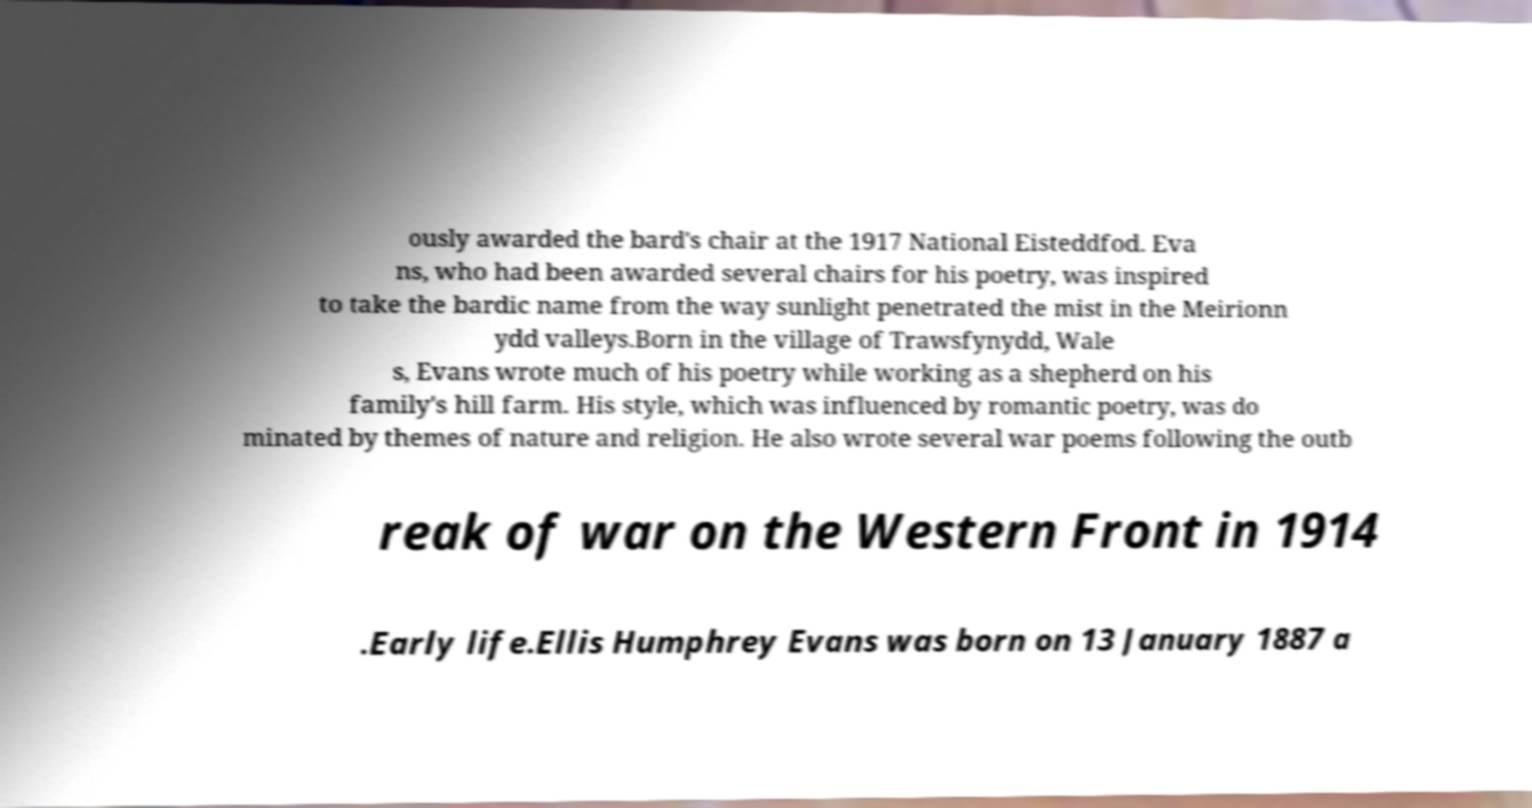Please identify and transcribe the text found in this image. ously awarded the bard's chair at the 1917 National Eisteddfod. Eva ns, who had been awarded several chairs for his poetry, was inspired to take the bardic name from the way sunlight penetrated the mist in the Meirionn ydd valleys.Born in the village of Trawsfynydd, Wale s, Evans wrote much of his poetry while working as a shepherd on his family's hill farm. His style, which was influenced by romantic poetry, was do minated by themes of nature and religion. He also wrote several war poems following the outb reak of war on the Western Front in 1914 .Early life.Ellis Humphrey Evans was born on 13 January 1887 a 